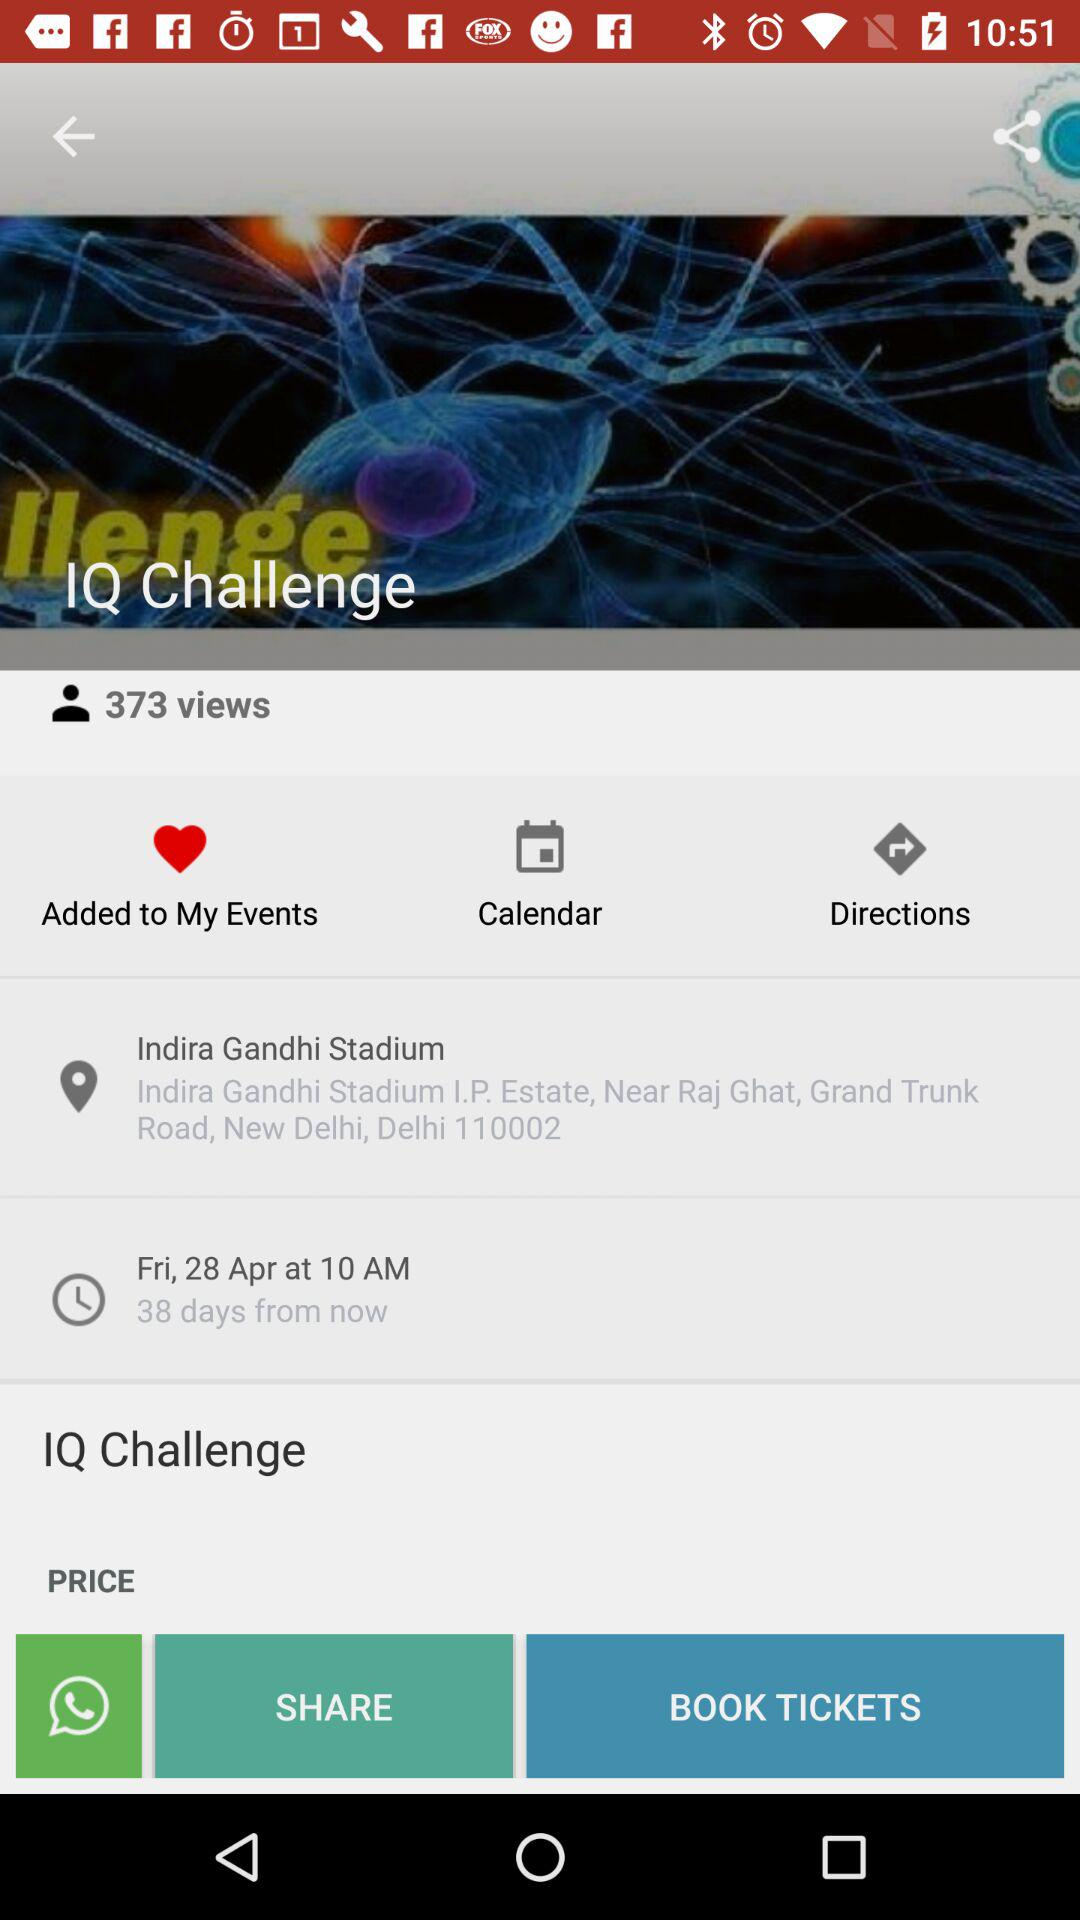How many people have viewed "IQ Challenge"? The number of people is 373. 